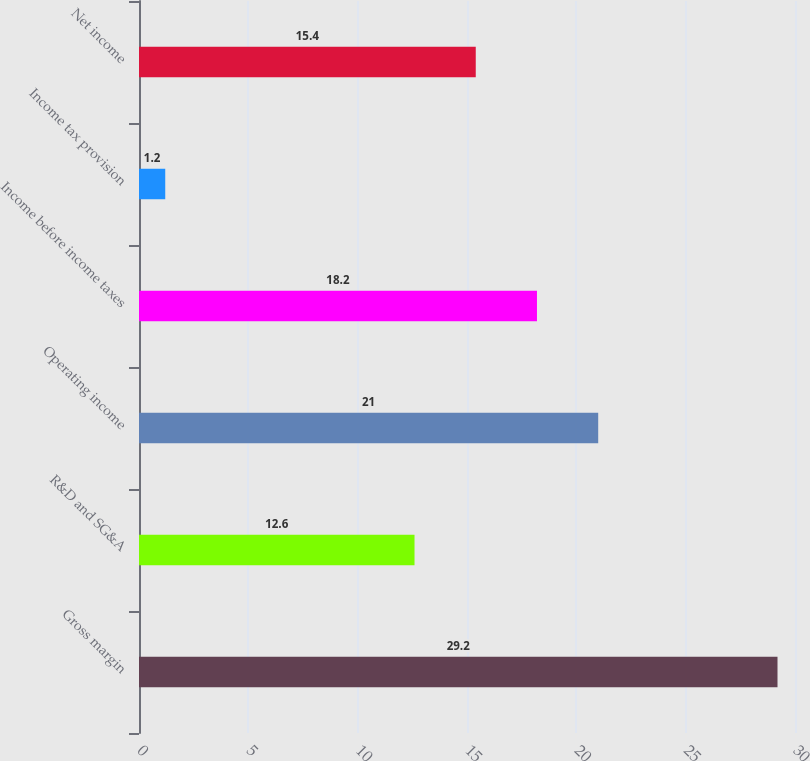<chart> <loc_0><loc_0><loc_500><loc_500><bar_chart><fcel>Gross margin<fcel>R&D and SG&A<fcel>Operating income<fcel>Income before income taxes<fcel>Income tax provision<fcel>Net income<nl><fcel>29.2<fcel>12.6<fcel>21<fcel>18.2<fcel>1.2<fcel>15.4<nl></chart> 